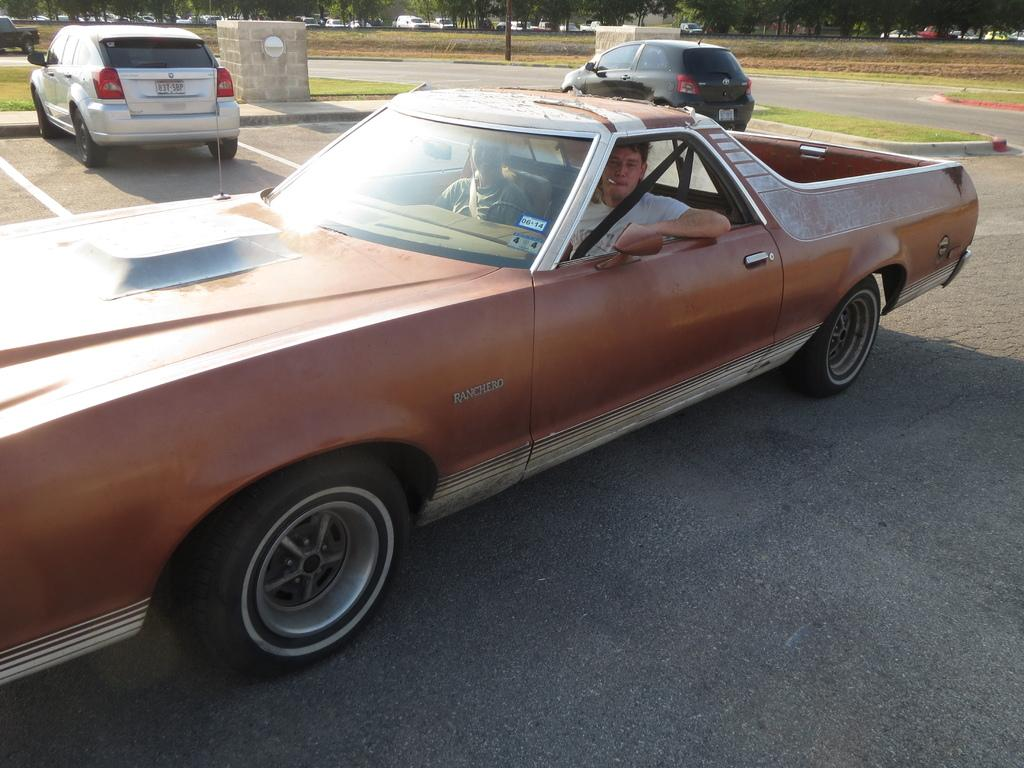What type of vehicles can be seen on the road in the image? There are cars on the road in the image. What type of vegetation is present in the image? There is grass in the image. What object can be seen standing upright in the image? There is a pole in the image. What can be seen in the background of the image? There are trees and vehicles visible in the background. What type of company is represented by the logo on the basketball in the image? There is no basketball or company logo present in the image. What scientific discovery is being made in the image? There is no scientific discovery being made in the image. 